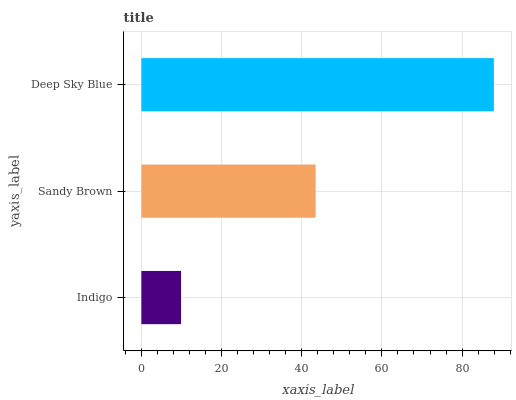Is Indigo the minimum?
Answer yes or no. Yes. Is Deep Sky Blue the maximum?
Answer yes or no. Yes. Is Sandy Brown the minimum?
Answer yes or no. No. Is Sandy Brown the maximum?
Answer yes or no. No. Is Sandy Brown greater than Indigo?
Answer yes or no. Yes. Is Indigo less than Sandy Brown?
Answer yes or no. Yes. Is Indigo greater than Sandy Brown?
Answer yes or no. No. Is Sandy Brown less than Indigo?
Answer yes or no. No. Is Sandy Brown the high median?
Answer yes or no. Yes. Is Sandy Brown the low median?
Answer yes or no. Yes. Is Deep Sky Blue the high median?
Answer yes or no. No. Is Indigo the low median?
Answer yes or no. No. 